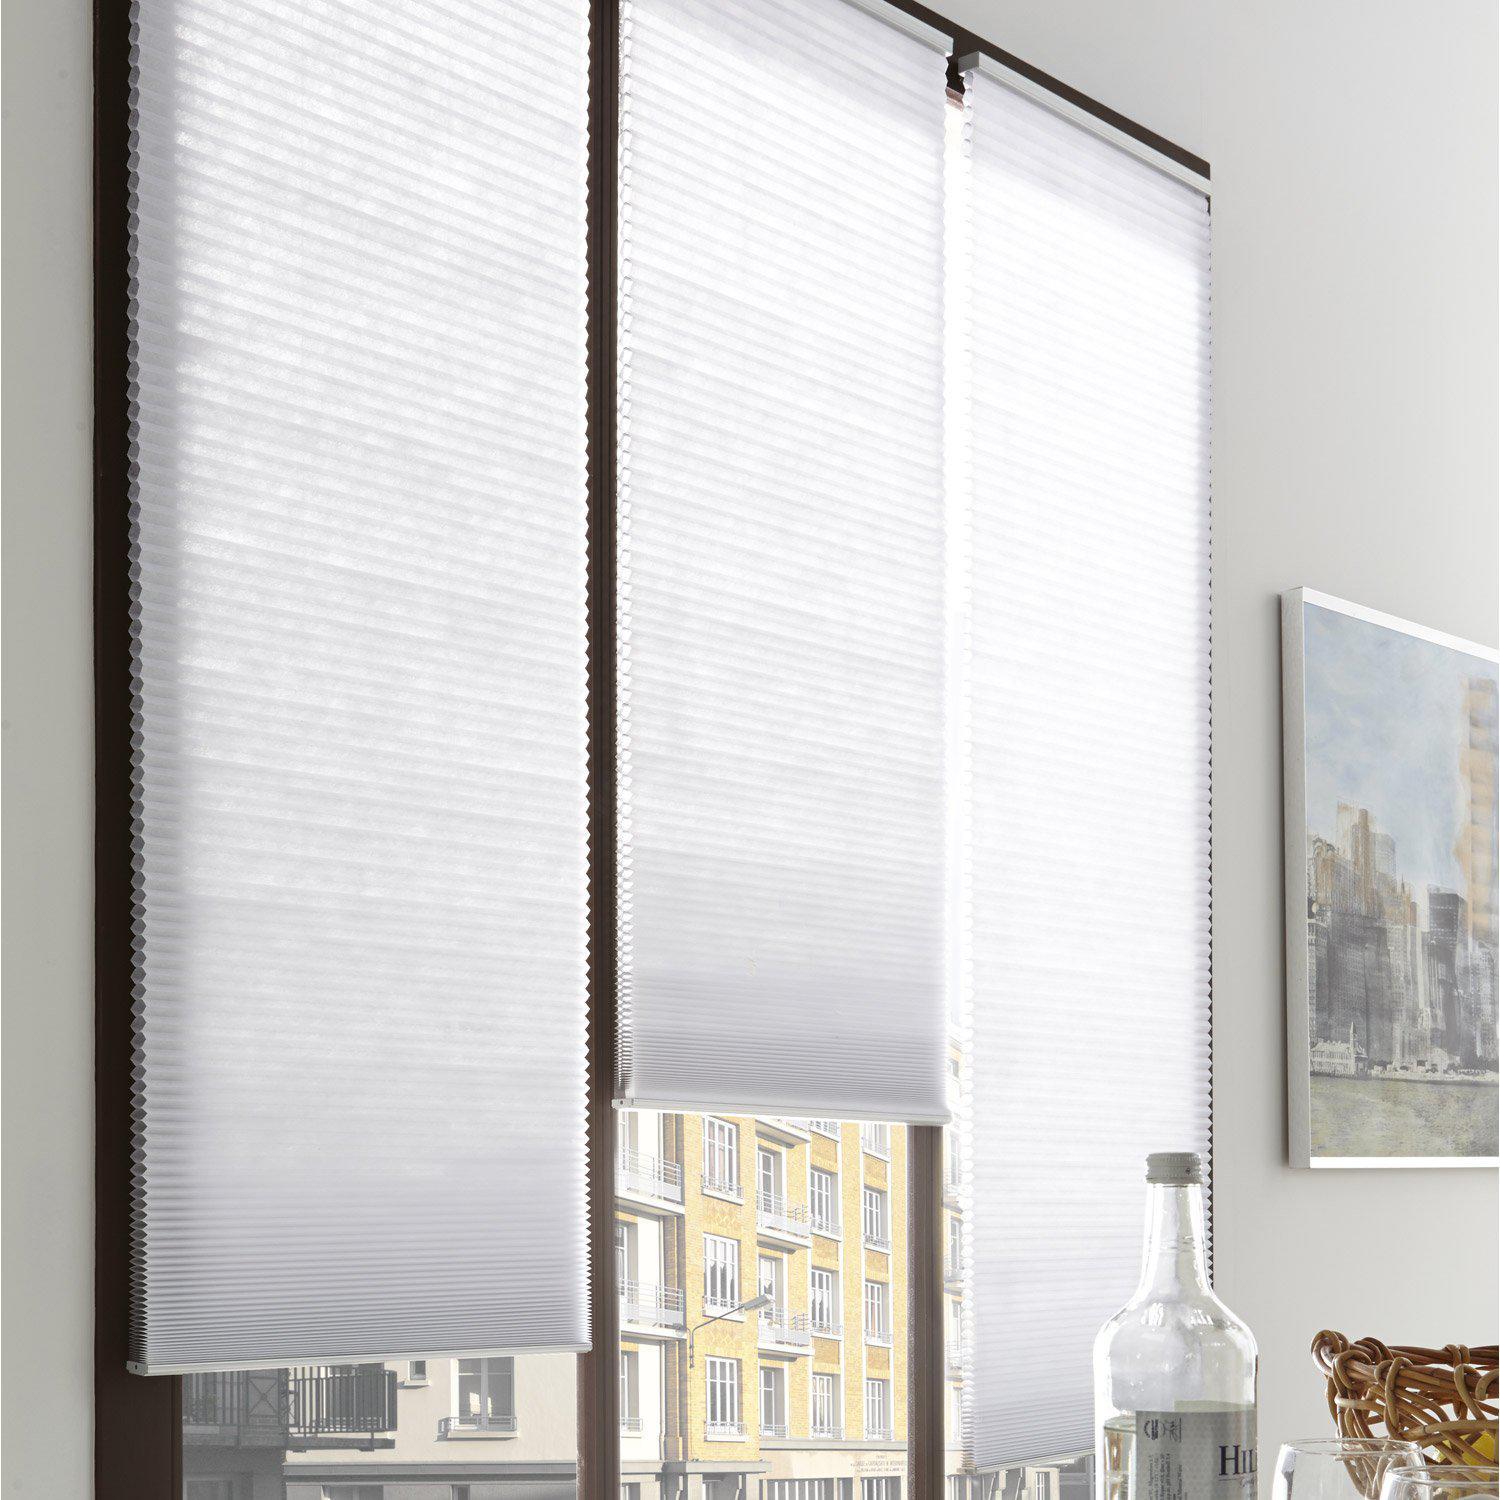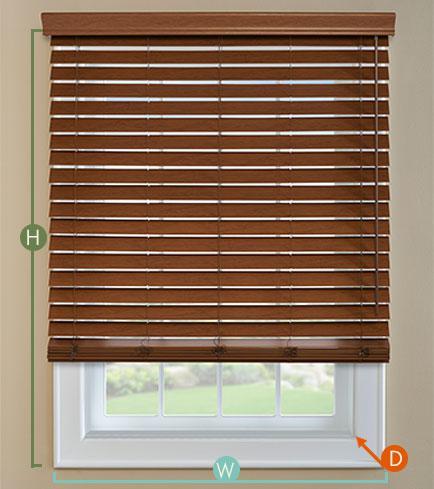The first image is the image on the left, the second image is the image on the right. For the images shown, is this caption "There are a total of four blinds." true? Answer yes or no. Yes. The first image is the image on the left, the second image is the image on the right. Considering the images on both sides, is "At least two shades are partially pulled up." valid? Answer yes or no. Yes. 